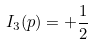<formula> <loc_0><loc_0><loc_500><loc_500>I _ { 3 } ( p ) = + { \frac { 1 } { 2 } }</formula> 